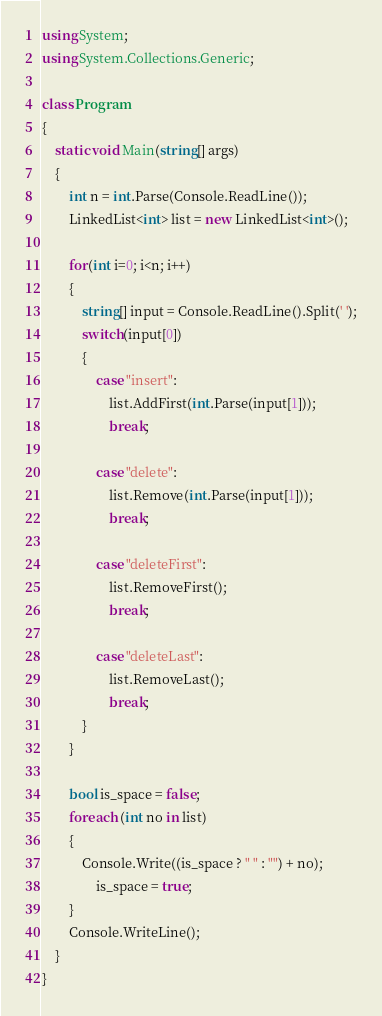Convert code to text. <code><loc_0><loc_0><loc_500><loc_500><_C#_>using System;
using System.Collections.Generic;
 
class Program
{
    static void Main(string[] args)
    {
        int n = int.Parse(Console.ReadLine());
        LinkedList<int> list = new LinkedList<int>();
 
        for(int i=0; i<n; i++)
        {
            string[] input = Console.ReadLine().Split(' ');
            switch(input[0])
            {
                case "insert":
                    list.AddFirst(int.Parse(input[1]));
                    break;
 
                case "delete":
                    list.Remove(int.Parse(input[1]));
                    break;
 
                case "deleteFirst":
                    list.RemoveFirst();
                    break;
 
                case "deleteLast":
                    list.RemoveLast();
                    break;
            }
        }
 
		bool is_space = false;
        foreach (int no in list)
        {
            Console.Write((is_space ? " " : "") + no);
				is_space = true;
        }
        Console.WriteLine();
    }
}</code> 